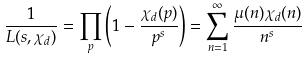<formula> <loc_0><loc_0><loc_500><loc_500>\frac { 1 } { L ( s , \chi _ { d } ) } = \prod _ { p } \left ( 1 - \frac { \chi _ { d } ( p ) } { p ^ { s } } \right ) = \sum _ { n = 1 } ^ { \infty } \frac { \mu ( n ) \chi _ { d } ( n ) } { n ^ { s } }</formula> 